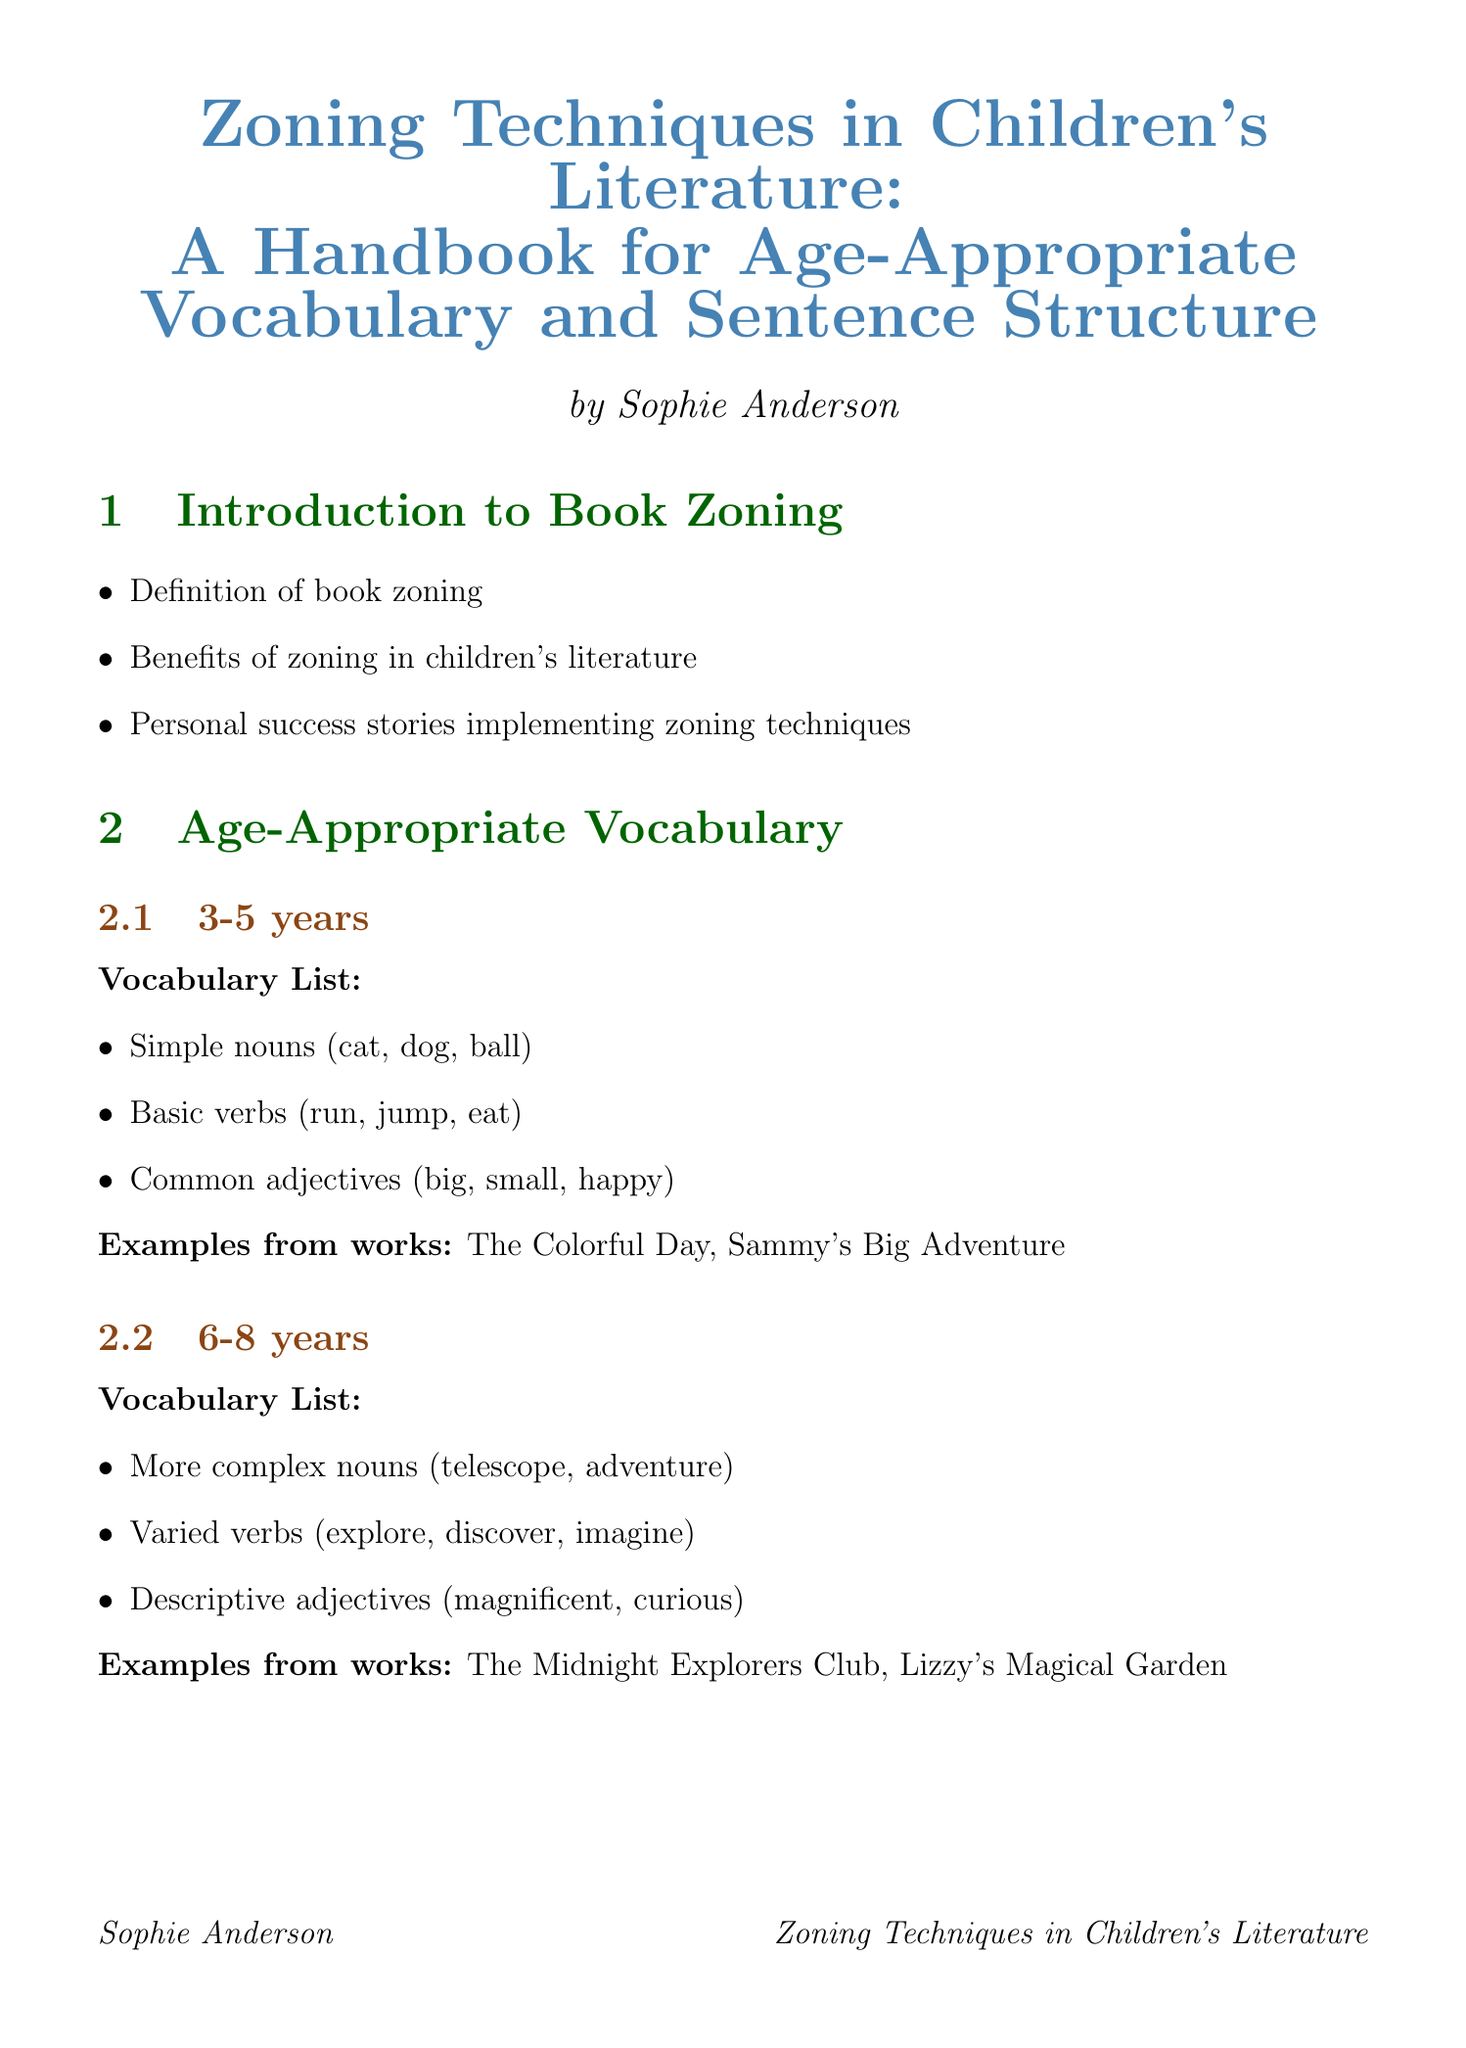What is the title of the handbook? The title is prominently displayed at the top of the document, indicating the focus on zoning techniques in children's literature.
Answer: Zoning Techniques in Children's Literature: A Handbook for Age-Appropriate Vocabulary and Sentence Structure Who is the author of the handbook? The author's name is mentioned right under the title, providing credit for the content.
Answer: Sophie Anderson What age group is targeted by the vocabulary list for 3-5 years? The age group is clearly stated in the section heading and corresponds to the vocabulary list provided.
Answer: 3-5 years What example book is listed for the 6-8 years vocabulary list? The example book is given in a clear format under the vocabulary list for each age group, showing where these words are used.
Answer: The Midnight Explorers Club What is the recommended sentence structure for beginner reading level? The structure is outlined in the corresponding section and summarizes the types of sentences appropriate for beginners.
Answer: Simple subject-verb sentences What is one principle of implementing zoning? The principles of zoning are highlighted in a list format, explaining how authors can structure their books effectively.
Answer: Gradual vocabulary progression within a single book What type of analysis is provided for "The Magic Treehouse" series? The analysis is summarized in a brief statement under the case studies section, illustrating the zoning technique used in that series.
Answer: Gradual increase in complexity across the series How many sections does the handbook contain? Counting the major sections in the document leads to identifying the total number of sections.
Answer: Eight 